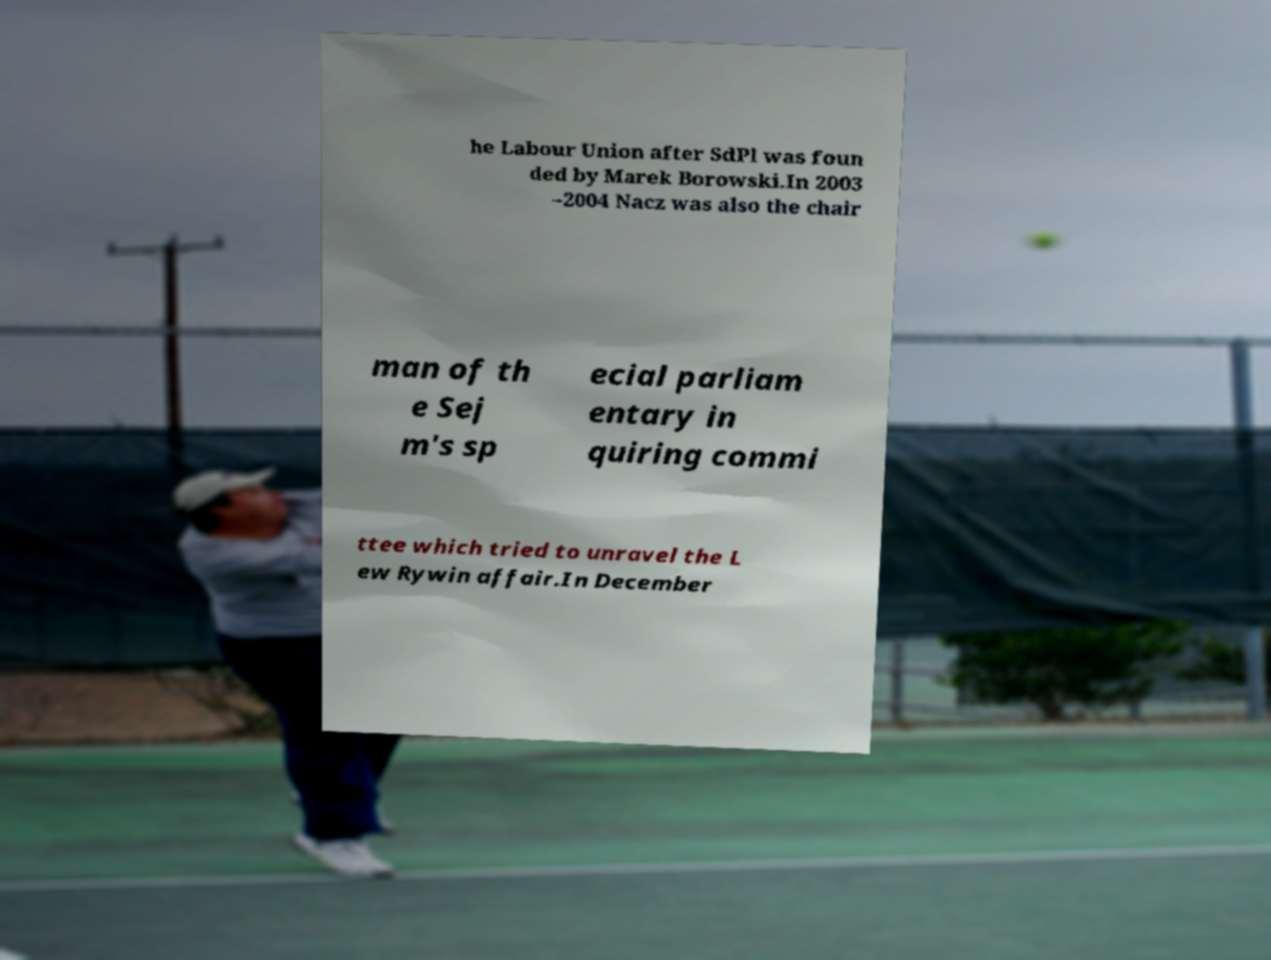Can you accurately transcribe the text from the provided image for me? he Labour Union after SdPl was foun ded by Marek Borowski.In 2003 –2004 Nacz was also the chair man of th e Sej m's sp ecial parliam entary in quiring commi ttee which tried to unravel the L ew Rywin affair.In December 